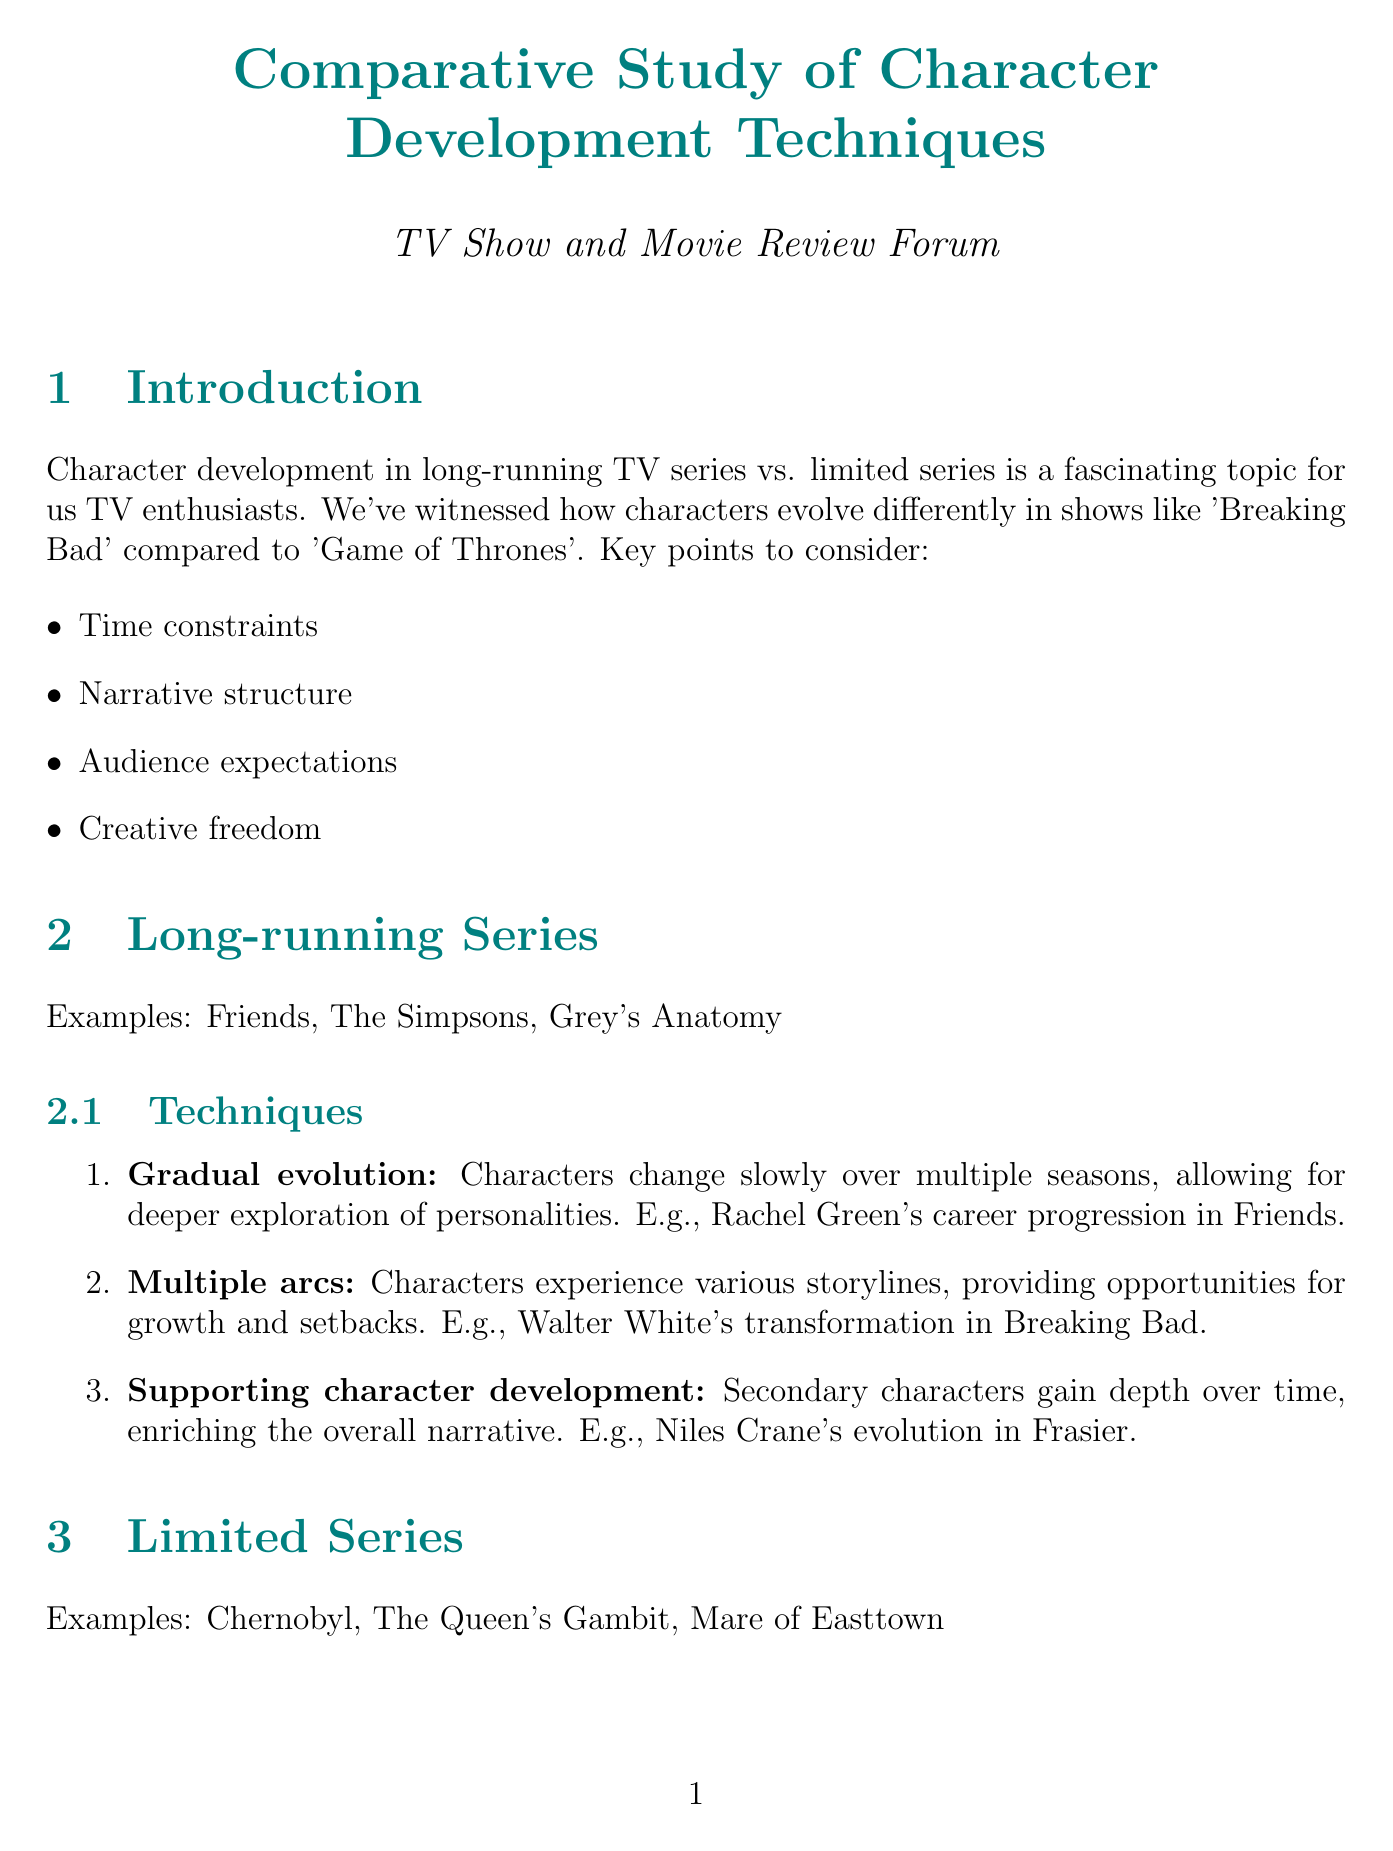What are three examples of long-running series? The document lists three examples of long-running series in the relevant section: Friends, The Simpsons, and Grey's Anatomy.
Answer: Friends, The Simpsons, Grey's Anatomy What character development technique is described as "characters change slowly over multiple seasons"? This technique is explicitly named in the document and is listed as "Gradual evolution" in the long-running series section.
Answer: Gradual evolution Which series showcases "Beth Harmon's journey"? The document mentions this specific character journey in the context of limited series examples, thus indicating the show referenced.
Answer: The Queen's Gambit What is the pacing of long-running series described as? The document clearly states that long-running series have a slower pacing, which allows for nuanced character development.
Answer: Slower What creative constraint do long-running series face? The document highlights a unique challenge for long-running series relating to their consistency over time.
Answer: Need to maintain character consistency over years What types of challenges do characters face in limited series? The document refers to significant obstacles that characters encounter, indicating the nature of their experiences in limited series.
Answer: Intense personal challenges Which approach allows for fan feedback to influence character development? The document underscores a specific storytelling impact related to long-running series, hinting at audience interaction.
Answer: Long-running series How do audiences' emotional investments differ between the two formats? The document provides a comparative perspective on audience connection to characters in long-running versus limited series.
Answer: Long-term attachments vs. intense but brief emotional investment 